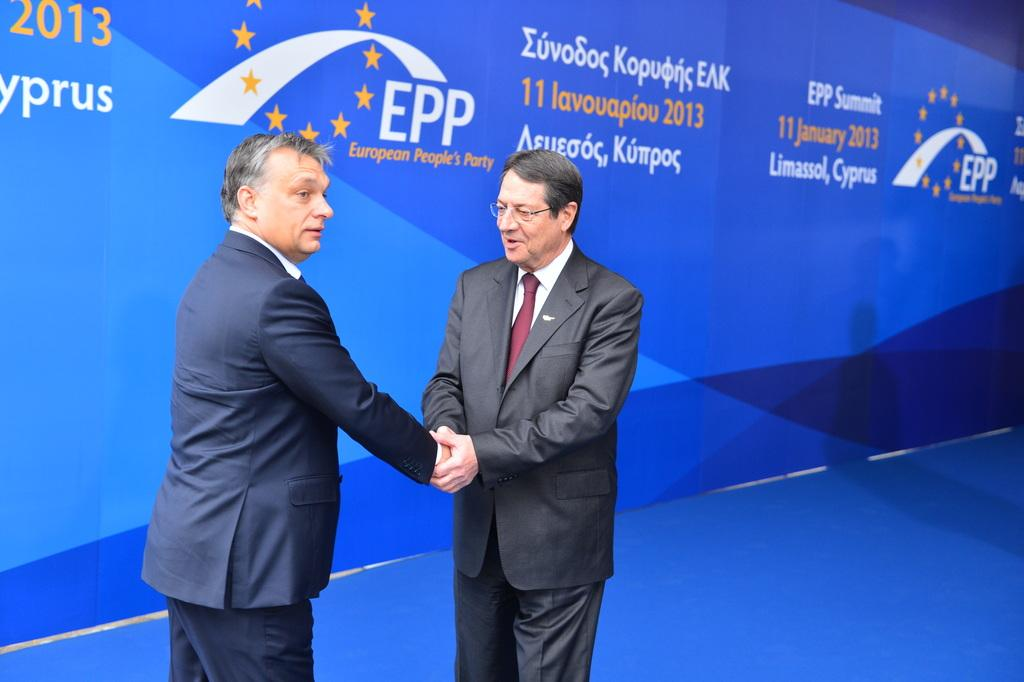How many people are in the image? There are two persons in the image. What are the two persons doing? The two persons are shaking hands. Can you describe one of the person's appearance? One person is wearing glasses (specs). What can be seen in the background of the image? There is a banner with text in the background of the image. What type of humor can be seen in the personified in the image? There is no humor personified in the image; it depicts two people shaking hands. Can you tell me where the bee is hiding in the image? There is no bee present in the image. 